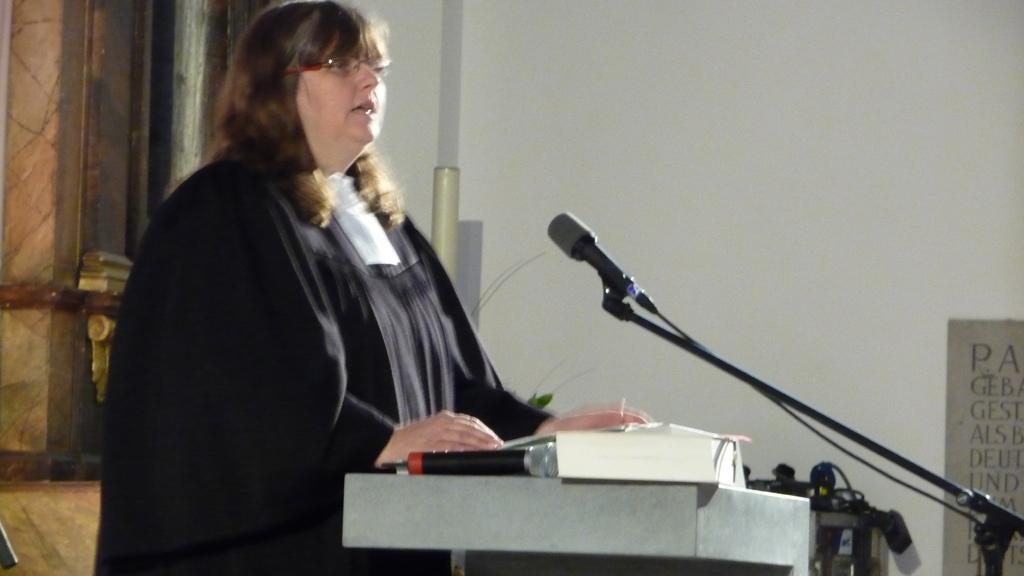Can you describe this image briefly? On the left side image I can see a woman wearing black color dress, standing in front of the podium and speaking something by looking at the right side. In front of her there is a mike stand. On the podium I can see a book and a mike. In the background I can see a wall to which a poster is attached and also there are some wires. 